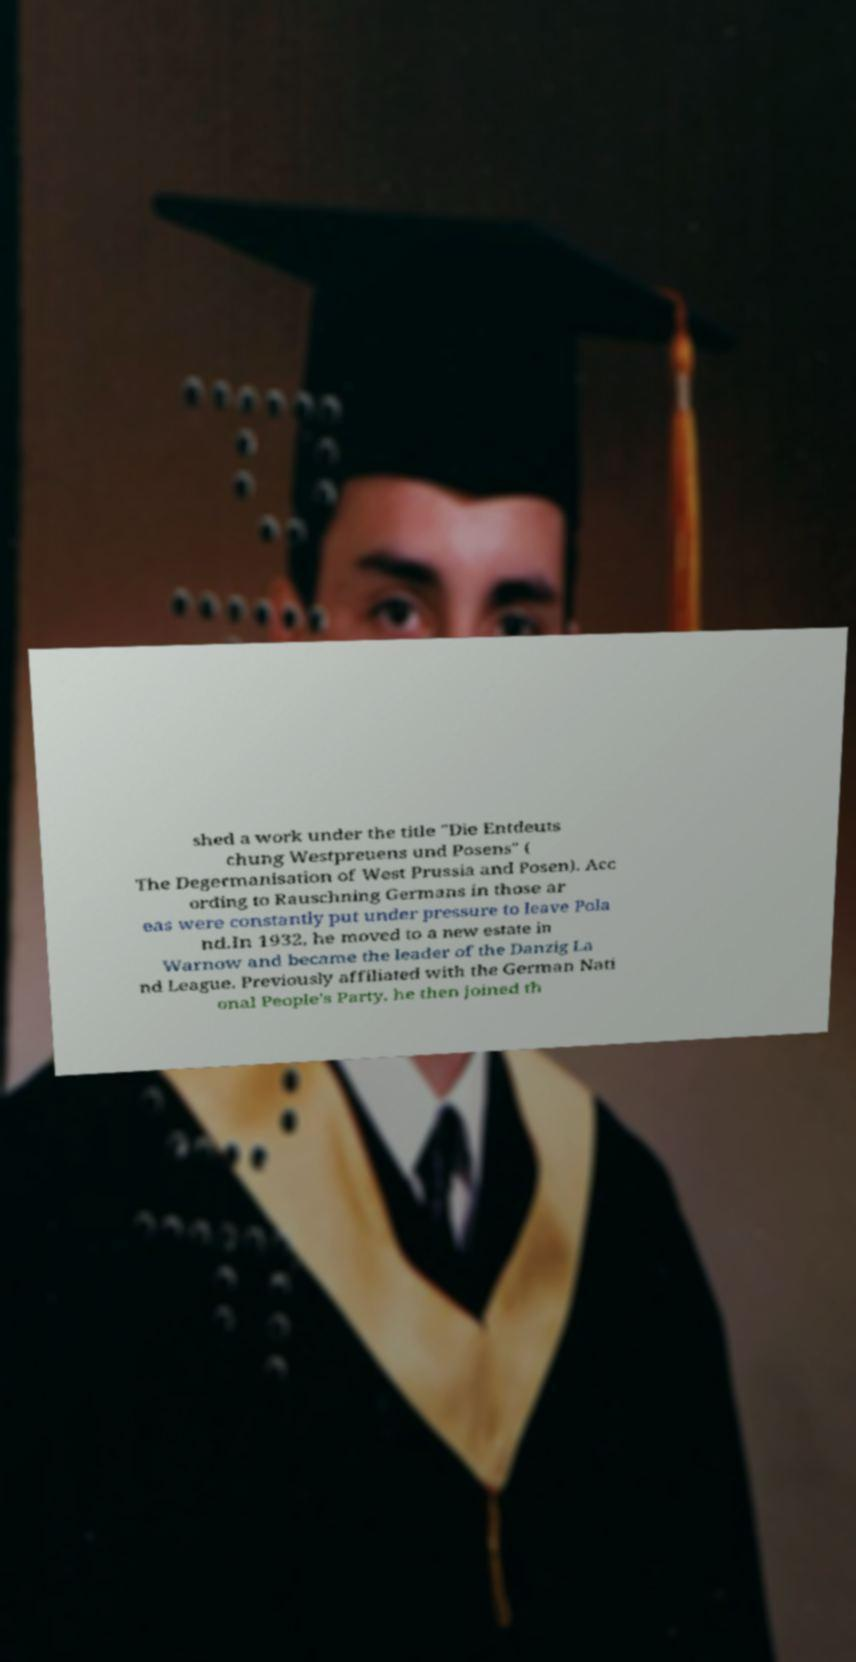There's text embedded in this image that I need extracted. Can you transcribe it verbatim? shed a work under the title "Die Entdeuts chung Westpreuens und Posens" ( The Degermanisation of West Prussia and Posen). Acc ording to Rauschning Germans in those ar eas were constantly put under pressure to leave Pola nd.In 1932, he moved to a new estate in Warnow and became the leader of the Danzig La nd League. Previously affiliated with the German Nati onal People's Party, he then joined th 